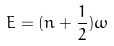<formula> <loc_0><loc_0><loc_500><loc_500>E = ( n + \frac { 1 } { 2 } ) \omega</formula> 